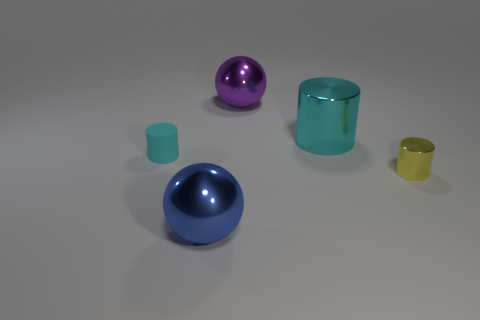Add 5 yellow metallic objects. How many objects exist? 10 Subtract all cylinders. How many objects are left? 2 Subtract all small yellow objects. Subtract all brown metal balls. How many objects are left? 4 Add 1 yellow things. How many yellow things are left? 2 Add 2 blue shiny objects. How many blue shiny objects exist? 3 Subtract 0 green spheres. How many objects are left? 5 